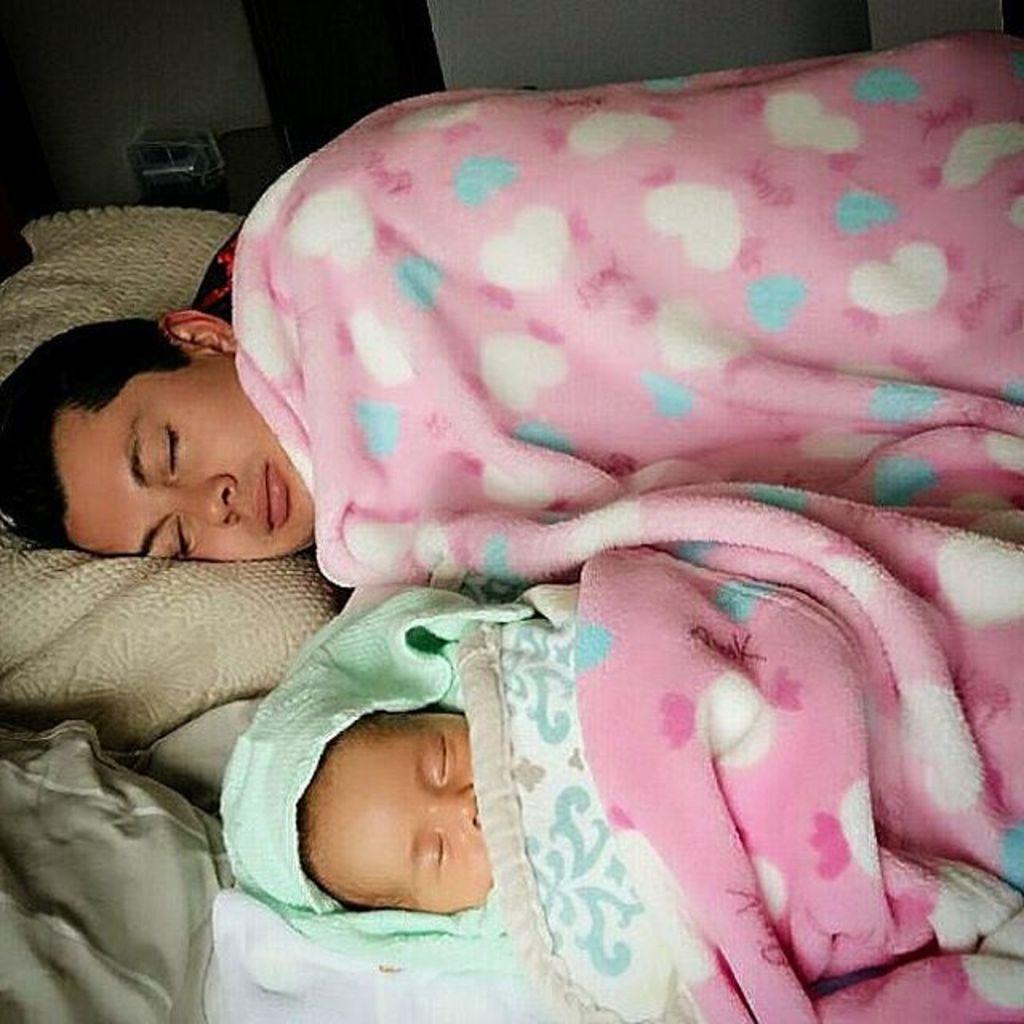Can you describe this image briefly? In this image there is one man and one baby sleeping on a bed, and there are some blankets and pillows and in the background there is a wall. 